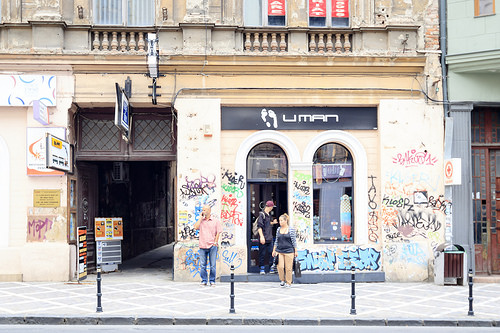<image>
Can you confirm if the woman is next to the man? Yes. The woman is positioned adjacent to the man, located nearby in the same general area. 